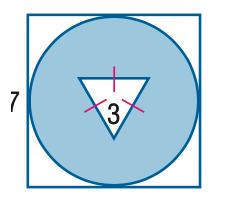Question: Find the area of the shaded region. Round to the nearest tenth.
Choices:
A. 26.8
B. 30.7
C. 31.7
D. 34.6
Answer with the letter. Answer: D 